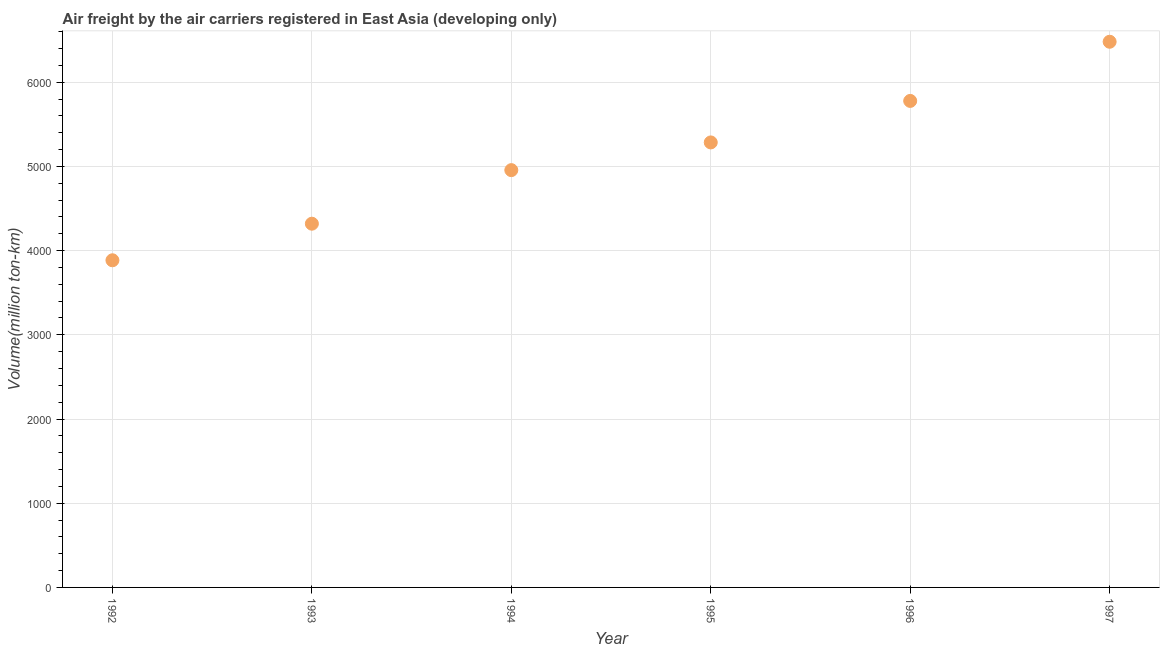What is the air freight in 1992?
Offer a very short reply. 3885.5. Across all years, what is the maximum air freight?
Provide a succinct answer. 6480.9. Across all years, what is the minimum air freight?
Give a very brief answer. 3885.5. What is the sum of the air freight?
Your answer should be compact. 3.07e+04. What is the difference between the air freight in 1993 and 1995?
Make the answer very short. -965.2. What is the average air freight per year?
Offer a very short reply. 5117.65. What is the median air freight?
Offer a very short reply. 5120.65. In how many years, is the air freight greater than 5600 million ton-km?
Make the answer very short. 2. Do a majority of the years between 1997 and 1994 (inclusive) have air freight greater than 4400 million ton-km?
Offer a terse response. Yes. What is the ratio of the air freight in 1993 to that in 1997?
Your answer should be compact. 0.67. Is the air freight in 1993 less than that in 1994?
Make the answer very short. Yes. What is the difference between the highest and the second highest air freight?
Provide a short and direct response. 702.7. What is the difference between the highest and the lowest air freight?
Offer a very short reply. 2595.4. In how many years, is the air freight greater than the average air freight taken over all years?
Offer a very short reply. 3. How many years are there in the graph?
Your answer should be very brief. 6. Are the values on the major ticks of Y-axis written in scientific E-notation?
Offer a terse response. No. Does the graph contain any zero values?
Your response must be concise. No. What is the title of the graph?
Offer a very short reply. Air freight by the air carriers registered in East Asia (developing only). What is the label or title of the Y-axis?
Keep it short and to the point. Volume(million ton-km). What is the Volume(million ton-km) in 1992?
Make the answer very short. 3885.5. What is the Volume(million ton-km) in 1993?
Give a very brief answer. 4320. What is the Volume(million ton-km) in 1994?
Make the answer very short. 4956.1. What is the Volume(million ton-km) in 1995?
Make the answer very short. 5285.2. What is the Volume(million ton-km) in 1996?
Ensure brevity in your answer.  5778.2. What is the Volume(million ton-km) in 1997?
Your answer should be compact. 6480.9. What is the difference between the Volume(million ton-km) in 1992 and 1993?
Keep it short and to the point. -434.5. What is the difference between the Volume(million ton-km) in 1992 and 1994?
Keep it short and to the point. -1070.6. What is the difference between the Volume(million ton-km) in 1992 and 1995?
Provide a succinct answer. -1399.7. What is the difference between the Volume(million ton-km) in 1992 and 1996?
Provide a succinct answer. -1892.7. What is the difference between the Volume(million ton-km) in 1992 and 1997?
Provide a succinct answer. -2595.4. What is the difference between the Volume(million ton-km) in 1993 and 1994?
Ensure brevity in your answer.  -636.1. What is the difference between the Volume(million ton-km) in 1993 and 1995?
Make the answer very short. -965.2. What is the difference between the Volume(million ton-km) in 1993 and 1996?
Offer a terse response. -1458.2. What is the difference between the Volume(million ton-km) in 1993 and 1997?
Keep it short and to the point. -2160.9. What is the difference between the Volume(million ton-km) in 1994 and 1995?
Offer a very short reply. -329.1. What is the difference between the Volume(million ton-km) in 1994 and 1996?
Make the answer very short. -822.1. What is the difference between the Volume(million ton-km) in 1994 and 1997?
Give a very brief answer. -1524.8. What is the difference between the Volume(million ton-km) in 1995 and 1996?
Provide a short and direct response. -493. What is the difference between the Volume(million ton-km) in 1995 and 1997?
Ensure brevity in your answer.  -1195.7. What is the difference between the Volume(million ton-km) in 1996 and 1997?
Make the answer very short. -702.7. What is the ratio of the Volume(million ton-km) in 1992 to that in 1993?
Your answer should be very brief. 0.9. What is the ratio of the Volume(million ton-km) in 1992 to that in 1994?
Offer a very short reply. 0.78. What is the ratio of the Volume(million ton-km) in 1992 to that in 1995?
Offer a very short reply. 0.73. What is the ratio of the Volume(million ton-km) in 1992 to that in 1996?
Ensure brevity in your answer.  0.67. What is the ratio of the Volume(million ton-km) in 1992 to that in 1997?
Give a very brief answer. 0.6. What is the ratio of the Volume(million ton-km) in 1993 to that in 1994?
Your answer should be very brief. 0.87. What is the ratio of the Volume(million ton-km) in 1993 to that in 1995?
Make the answer very short. 0.82. What is the ratio of the Volume(million ton-km) in 1993 to that in 1996?
Your response must be concise. 0.75. What is the ratio of the Volume(million ton-km) in 1993 to that in 1997?
Your answer should be compact. 0.67. What is the ratio of the Volume(million ton-km) in 1994 to that in 1995?
Offer a terse response. 0.94. What is the ratio of the Volume(million ton-km) in 1994 to that in 1996?
Ensure brevity in your answer.  0.86. What is the ratio of the Volume(million ton-km) in 1994 to that in 1997?
Give a very brief answer. 0.77. What is the ratio of the Volume(million ton-km) in 1995 to that in 1996?
Your answer should be very brief. 0.92. What is the ratio of the Volume(million ton-km) in 1995 to that in 1997?
Give a very brief answer. 0.82. What is the ratio of the Volume(million ton-km) in 1996 to that in 1997?
Give a very brief answer. 0.89. 